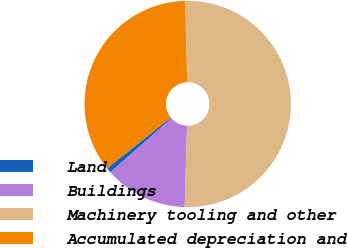Convert chart. <chart><loc_0><loc_0><loc_500><loc_500><pie_chart><fcel>Land<fcel>Buildings<fcel>Machinery tooling and other<fcel>Accumulated depreciation and<nl><fcel>0.8%<fcel>13.01%<fcel>50.85%<fcel>35.35%<nl></chart> 